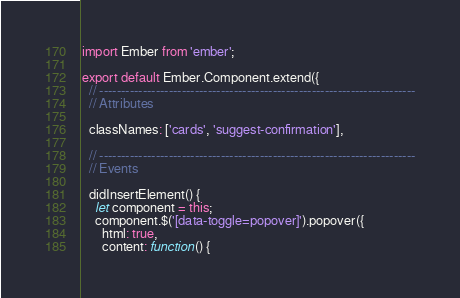<code> <loc_0><loc_0><loc_500><loc_500><_JavaScript_>import Ember from 'ember';

export default Ember.Component.extend({
  // -------------------------------------------------------------------------
  // Attributes

  classNames: ['cards', 'suggest-confirmation'],

  // -------------------------------------------------------------------------
  // Events

  didInsertElement() {
    let component = this;
    component.$('[data-toggle=popover]').popover({
      html: true,
      content: function() {</code> 